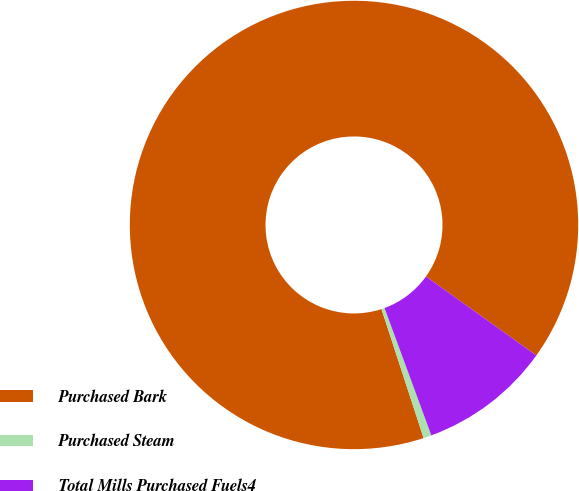Convert chart to OTSL. <chart><loc_0><loc_0><loc_500><loc_500><pie_chart><fcel>Purchased Bark<fcel>Purchased Steam<fcel>Total Mills Purchased Fuels4<nl><fcel>89.91%<fcel>0.58%<fcel>9.51%<nl></chart> 